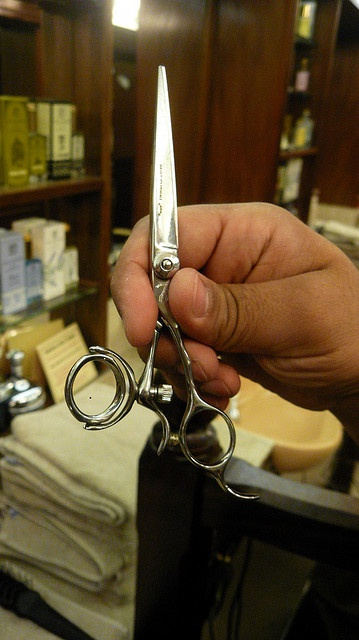Describe the objects in this image and their specific colors. I can see people in tan, brown, maroon, black, and salmon tones, scissors in tan, black, ivory, khaki, and olive tones, and toilet in tan and olive tones in this image. 